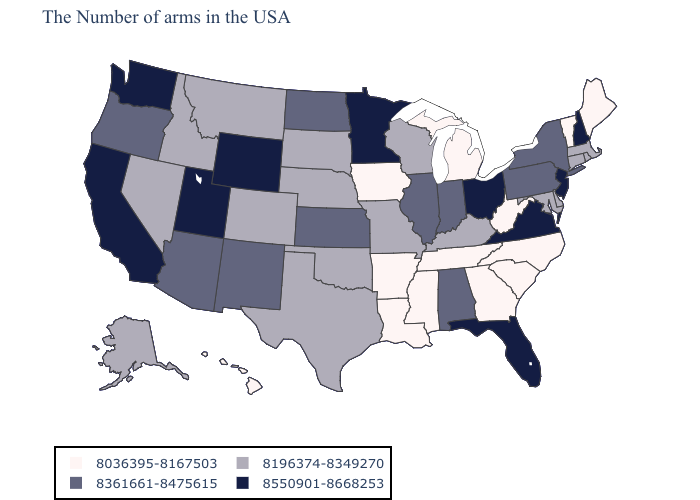Name the states that have a value in the range 8550901-8668253?
Give a very brief answer. New Hampshire, New Jersey, Virginia, Ohio, Florida, Minnesota, Wyoming, Utah, California, Washington. What is the value of South Dakota?
Give a very brief answer. 8196374-8349270. What is the lowest value in the Northeast?
Concise answer only. 8036395-8167503. How many symbols are there in the legend?
Give a very brief answer. 4. Among the states that border Texas , does Oklahoma have the lowest value?
Write a very short answer. No. Which states have the highest value in the USA?
Concise answer only. New Hampshire, New Jersey, Virginia, Ohio, Florida, Minnesota, Wyoming, Utah, California, Washington. What is the value of Nevada?
Answer briefly. 8196374-8349270. What is the highest value in states that border North Dakota?
Keep it brief. 8550901-8668253. What is the lowest value in states that border Kentucky?
Keep it brief. 8036395-8167503. What is the value of Alabama?
Short answer required. 8361661-8475615. Name the states that have a value in the range 8196374-8349270?
Answer briefly. Massachusetts, Rhode Island, Connecticut, Delaware, Maryland, Kentucky, Wisconsin, Missouri, Nebraska, Oklahoma, Texas, South Dakota, Colorado, Montana, Idaho, Nevada, Alaska. What is the value of Alaska?
Quick response, please. 8196374-8349270. Does Texas have the same value as Vermont?
Write a very short answer. No. Is the legend a continuous bar?
Answer briefly. No. Does Wyoming have the same value as Minnesota?
Write a very short answer. Yes. 